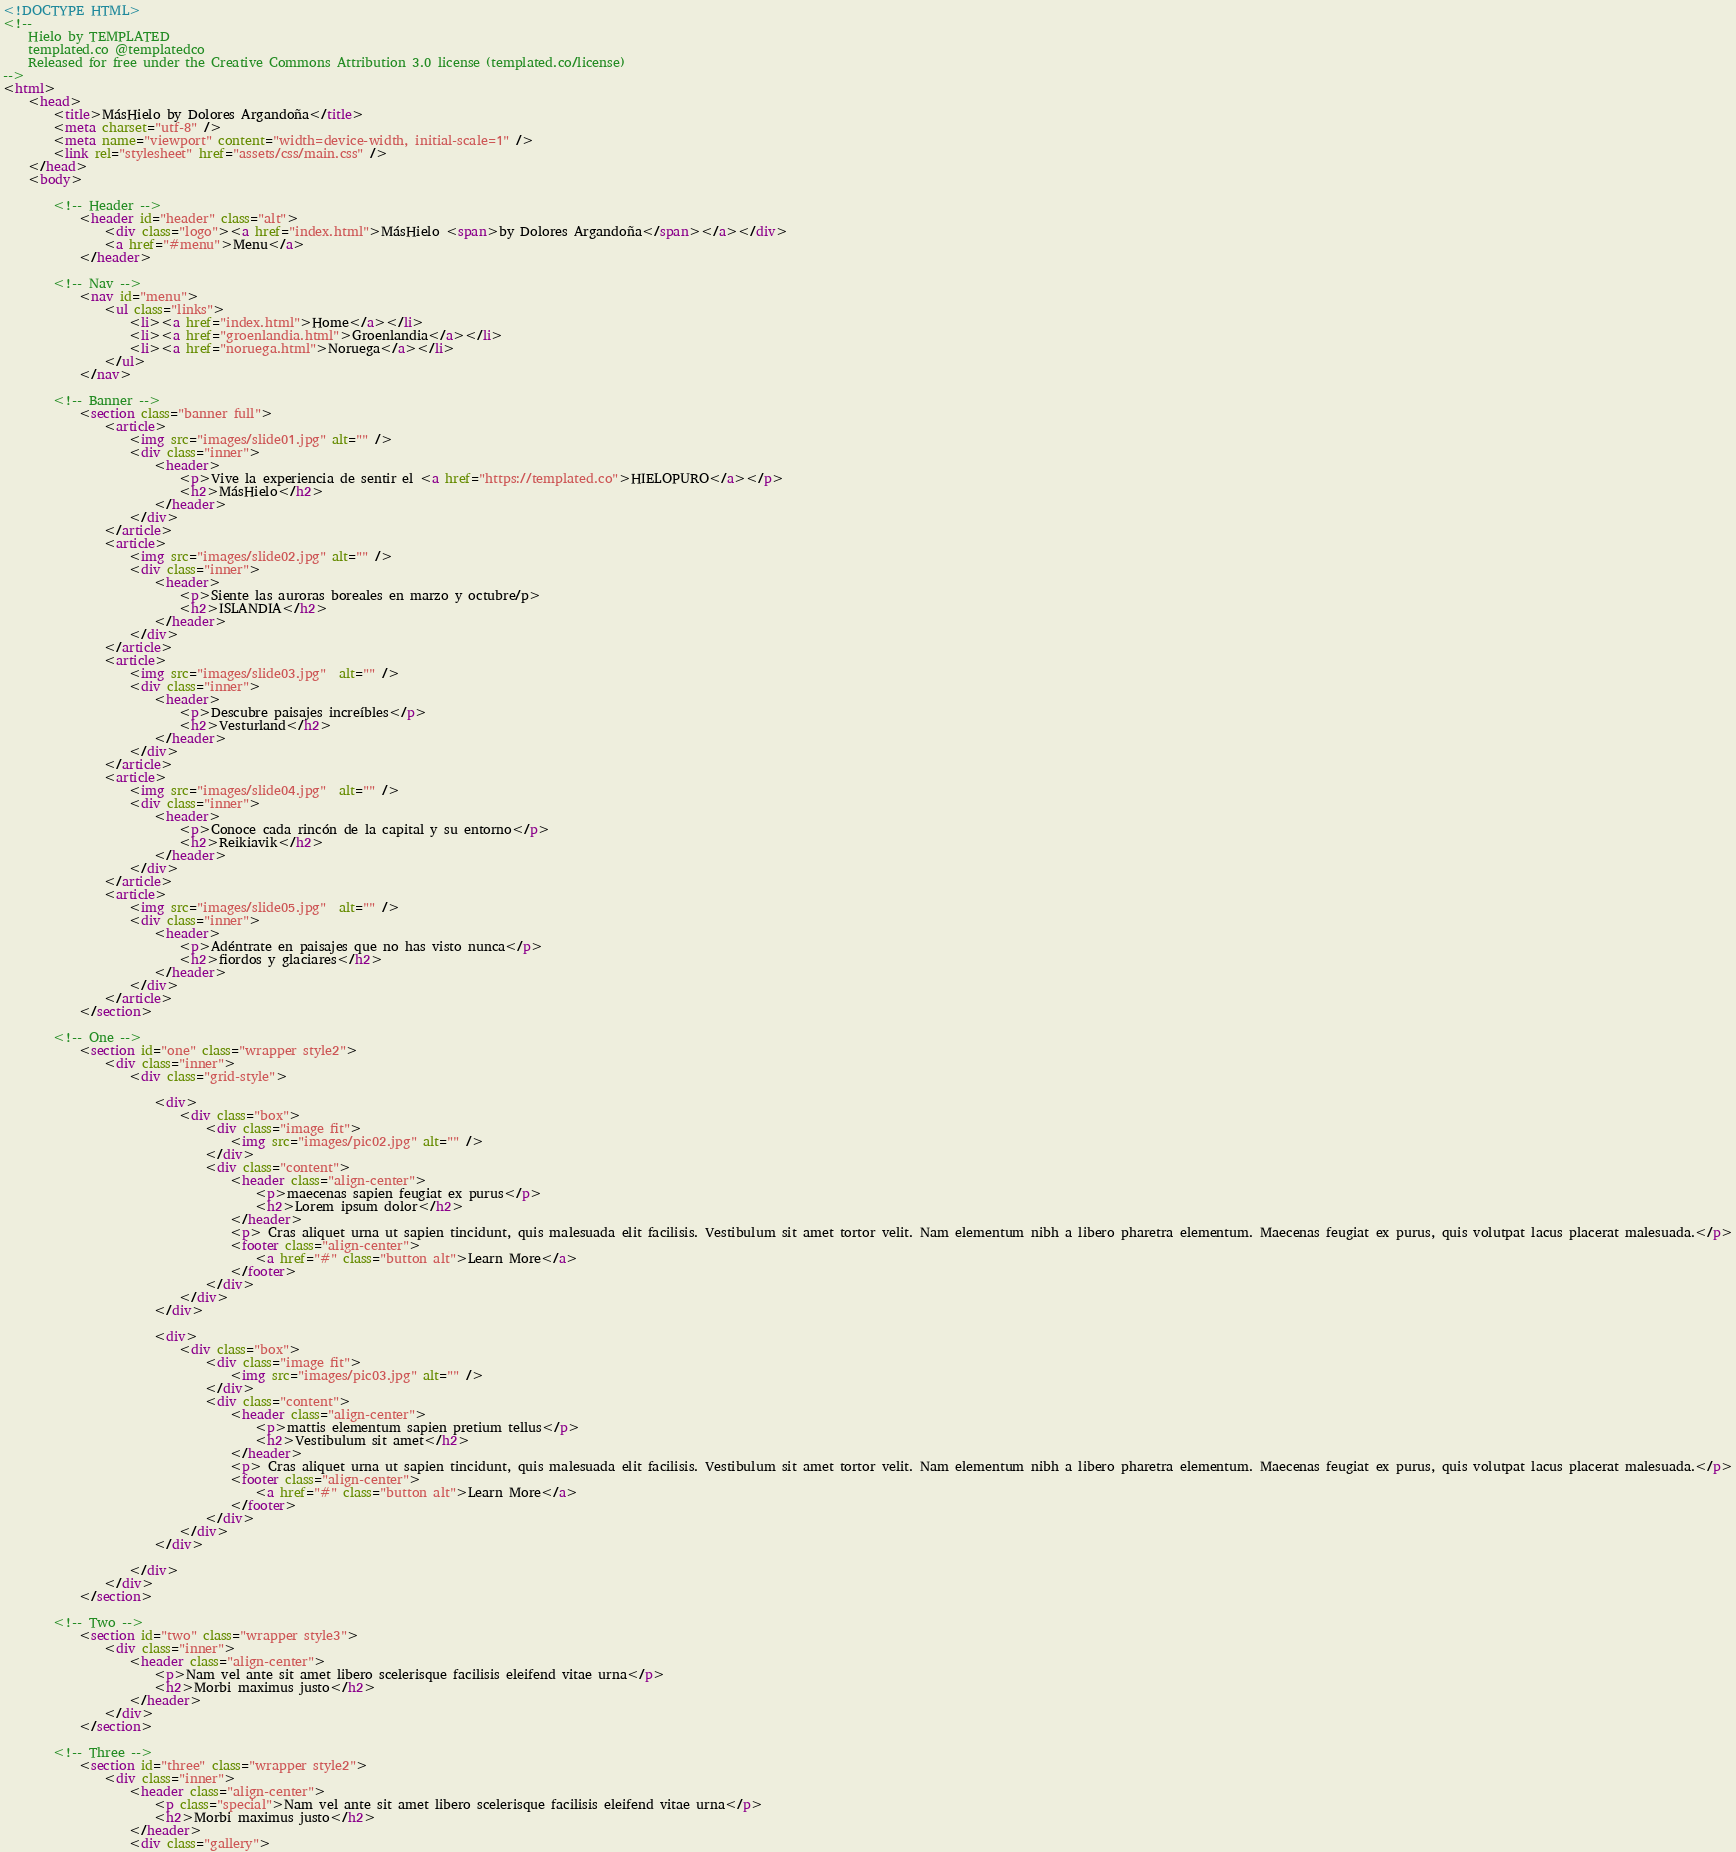Convert code to text. <code><loc_0><loc_0><loc_500><loc_500><_HTML_><!DOCTYPE HTML>
<!--
	Hielo by TEMPLATED
	templated.co @templatedco
	Released for free under the Creative Commons Attribution 3.0 license (templated.co/license)
-->
<html>
	<head>
		<title>MásHielo by Dolores Argandoña</title>
		<meta charset="utf-8" />
		<meta name="viewport" content="width=device-width, initial-scale=1" />
		<link rel="stylesheet" href="assets/css/main.css" />
	</head>
	<body>

		<!-- Header -->
			<header id="header" class="alt">
				<div class="logo"><a href="index.html">MásHielo <span>by Dolores Argandoña</span></a></div>
				<a href="#menu">Menu</a>
			</header>

		<!-- Nav -->
			<nav id="menu">
				<ul class="links">
					<li><a href="index.html">Home</a></li>
					<li><a href="groenlandia.html">Groenlandia</a></li>
					<li><a href="noruega.html">Noruega</a></li>
				</ul>
			</nav>

		<!-- Banner -->
			<section class="banner full">
				<article>
					<img src="images/slide01.jpg" alt="" />
					<div class="inner">
						<header>
							<p>Vive la experiencia de sentir el <a href="https://templated.co">HIELOPURO</a></p>
							<h2>MásHielo</h2>
						</header>
					</div>
				</article>
				<article>
					<img src="images/slide02.jpg" alt="" />
					<div class="inner">
						<header>
							<p>Siente las auroras boreales en marzo y octubre/p>
							<h2>ISLANDIA</h2>
						</header>
					</div>
				</article>
				<article>
					<img src="images/slide03.jpg"  alt="" />
					<div class="inner">
						<header>
							<p>Descubre paisajes increíbles</p>
							<h2>Vesturland</h2>
						</header>
					</div>
				</article>
				<article>
					<img src="images/slide04.jpg"  alt="" />
					<div class="inner">
						<header>
							<p>Conoce cada rincón de la capital y su entorno</p>
							<h2>Reikiavik</h2>
						</header>
					</div>
				</article>
				<article>
					<img src="images/slide05.jpg"  alt="" />
					<div class="inner">
						<header>
							<p>Adéntrate en paisajes que no has visto nunca</p>
							<h2>fiordos y glaciares</h2>
						</header>
					</div>
				</article>
			</section>

		<!-- One -->
			<section id="one" class="wrapper style2">
				<div class="inner">
					<div class="grid-style">

						<div>
							<div class="box">
								<div class="image fit">
									<img src="images/pic02.jpg" alt="" />
								</div>
								<div class="content">
									<header class="align-center">
										<p>maecenas sapien feugiat ex purus</p>
										<h2>Lorem ipsum dolor</h2>
									</header>
									<p> Cras aliquet urna ut sapien tincidunt, quis malesuada elit facilisis. Vestibulum sit amet tortor velit. Nam elementum nibh a libero pharetra elementum. Maecenas feugiat ex purus, quis volutpat lacus placerat malesuada.</p>
									<footer class="align-center">
										<a href="#" class="button alt">Learn More</a>
									</footer>
								</div>
							</div>
						</div>

						<div>
							<div class="box">
								<div class="image fit">
									<img src="images/pic03.jpg" alt="" />
								</div>
								<div class="content">
									<header class="align-center">
										<p>mattis elementum sapien pretium tellus</p>
										<h2>Vestibulum sit amet</h2>
									</header>
									<p> Cras aliquet urna ut sapien tincidunt, quis malesuada elit facilisis. Vestibulum sit amet tortor velit. Nam elementum nibh a libero pharetra elementum. Maecenas feugiat ex purus, quis volutpat lacus placerat malesuada.</p>
									<footer class="align-center">
										<a href="#" class="button alt">Learn More</a>
									</footer>
								</div>
							</div>
						</div>

					</div>
				</div>
			</section>

		<!-- Two -->
			<section id="two" class="wrapper style3">
				<div class="inner">
					<header class="align-center">
						<p>Nam vel ante sit amet libero scelerisque facilisis eleifend vitae urna</p>
						<h2>Morbi maximus justo</h2>
					</header>
				</div>
			</section>

		<!-- Three -->
			<section id="three" class="wrapper style2">
				<div class="inner">
					<header class="align-center">
						<p class="special">Nam vel ante sit amet libero scelerisque facilisis eleifend vitae urna</p>
						<h2>Morbi maximus justo</h2>
					</header>
					<div class="gallery"></code> 